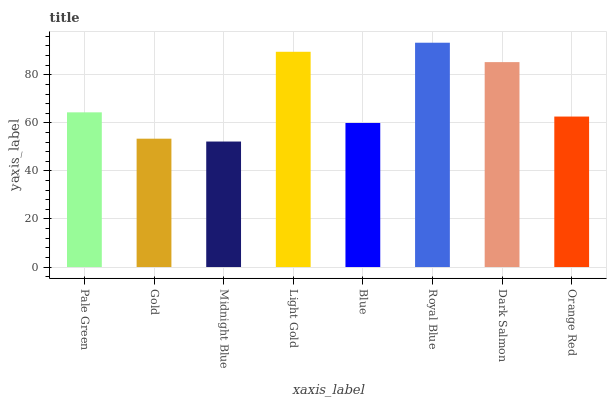Is Midnight Blue the minimum?
Answer yes or no. Yes. Is Royal Blue the maximum?
Answer yes or no. Yes. Is Gold the minimum?
Answer yes or no. No. Is Gold the maximum?
Answer yes or no. No. Is Pale Green greater than Gold?
Answer yes or no. Yes. Is Gold less than Pale Green?
Answer yes or no. Yes. Is Gold greater than Pale Green?
Answer yes or no. No. Is Pale Green less than Gold?
Answer yes or no. No. Is Pale Green the high median?
Answer yes or no. Yes. Is Orange Red the low median?
Answer yes or no. Yes. Is Blue the high median?
Answer yes or no. No. Is Blue the low median?
Answer yes or no. No. 